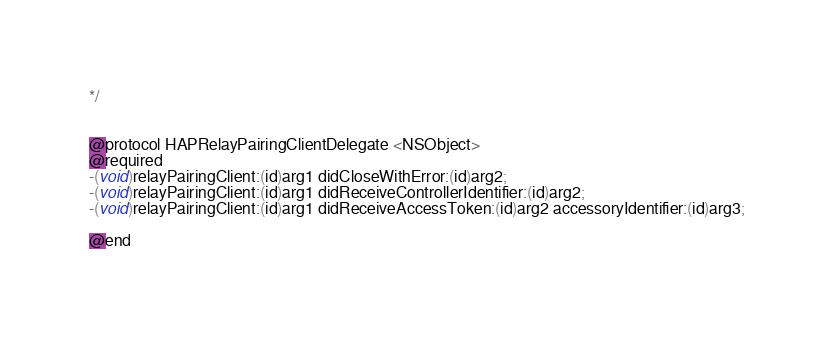<code> <loc_0><loc_0><loc_500><loc_500><_C_>*/


@protocol HAPRelayPairingClientDelegate <NSObject>
@required
-(void)relayPairingClient:(id)arg1 didCloseWithError:(id)arg2;
-(void)relayPairingClient:(id)arg1 didReceiveControllerIdentifier:(id)arg2;
-(void)relayPairingClient:(id)arg1 didReceiveAccessToken:(id)arg2 accessoryIdentifier:(id)arg3;

@end

</code> 